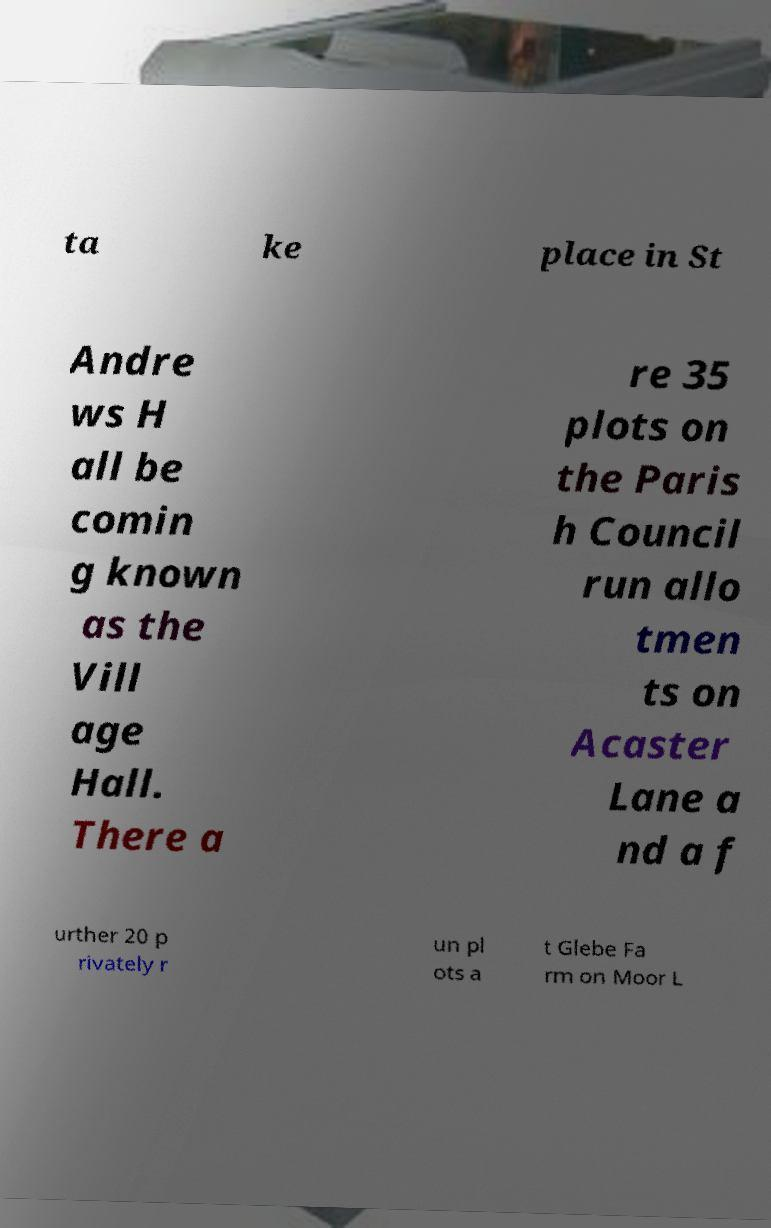There's text embedded in this image that I need extracted. Can you transcribe it verbatim? ta ke place in St Andre ws H all be comin g known as the Vill age Hall. There a re 35 plots on the Paris h Council run allo tmen ts on Acaster Lane a nd a f urther 20 p rivately r un pl ots a t Glebe Fa rm on Moor L 